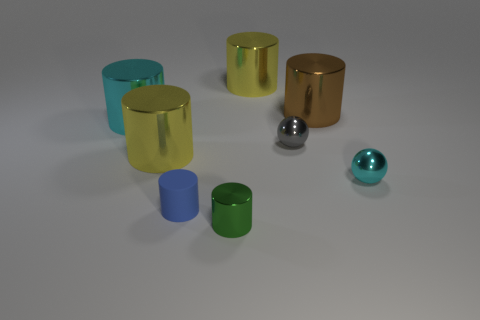Is the number of big yellow metallic things that are on the right side of the small cyan metallic object greater than the number of brown metal things?
Offer a terse response. No. Is the size of the brown shiny cylinder the same as the blue matte object?
Keep it short and to the point. No. There is another tiny cylinder that is made of the same material as the brown cylinder; what is its color?
Your answer should be very brief. Green. Is the number of small cyan metallic objects behind the cyan cylinder the same as the number of matte cylinders that are behind the gray shiny thing?
Offer a terse response. Yes. There is a metallic thing that is in front of the tiny metallic object to the right of the gray ball; what is its shape?
Your answer should be compact. Cylinder. There is a green object that is the same shape as the large cyan metal thing; what material is it?
Keep it short and to the point. Metal. The other rubber thing that is the same size as the green object is what color?
Give a very brief answer. Blue. Are there an equal number of green metallic cylinders that are in front of the green object and tiny gray shiny things?
Provide a short and direct response. No. There is a small metallic cylinder that is left of the sphere that is in front of the tiny gray object; what is its color?
Provide a short and direct response. Green. How big is the sphere in front of the yellow cylinder that is left of the tiny green metal cylinder?
Ensure brevity in your answer.  Small. 